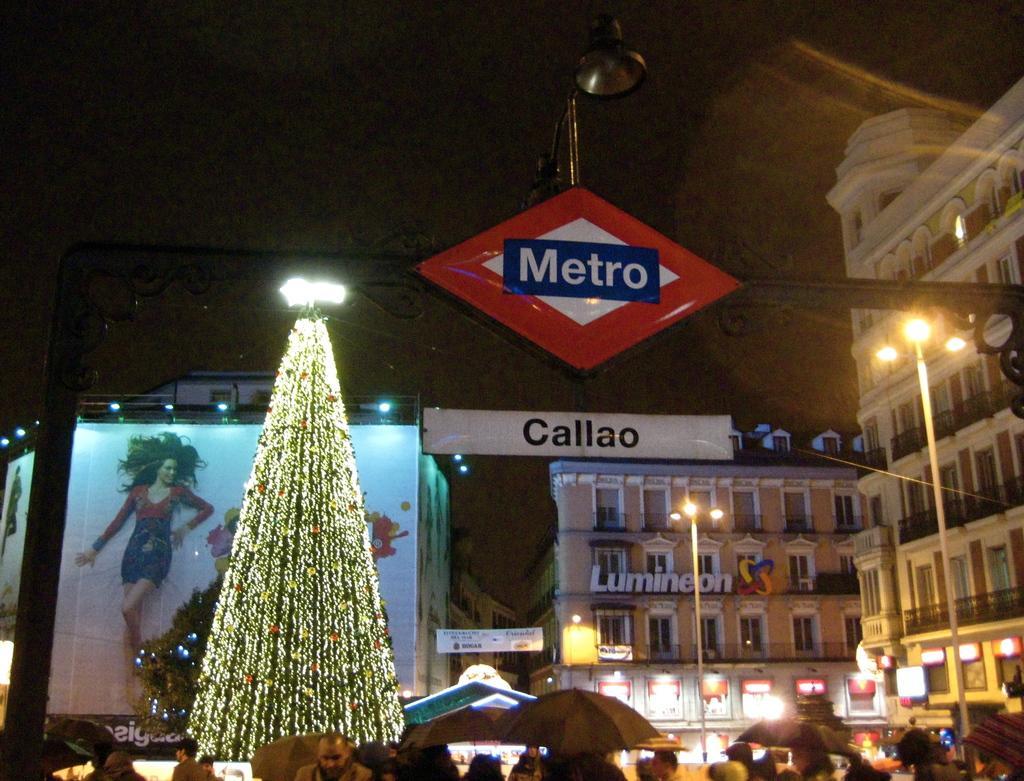Could you give a brief overview of what you see in this image? In this image we can see some buildings with windows and a sign board. We can also see street poles, a sign board with text on it, a banner with some pictures and lights and a tree which is decorated with lights. On the bottom of the image we can see a group of people. In that some are holding the umbrellas. 